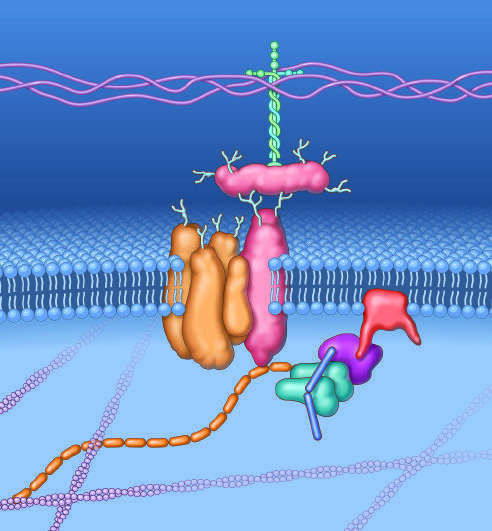s a key set of connections made by dystrophin?
Answer the question using a single word or phrase. Yes 